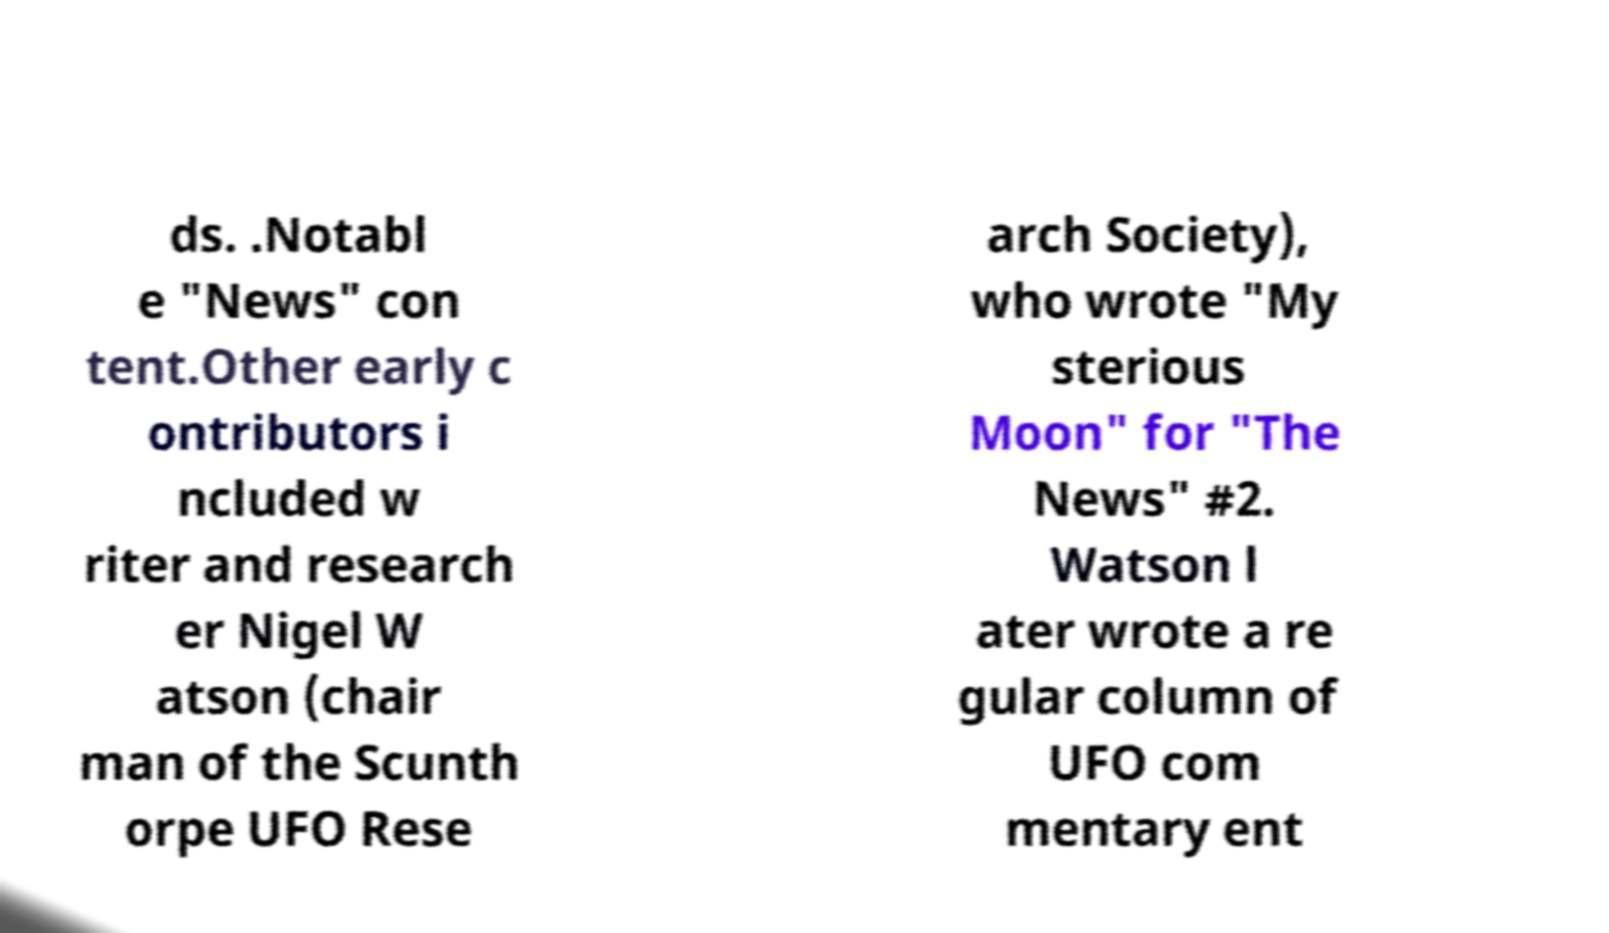For documentation purposes, I need the text within this image transcribed. Could you provide that? ds. .Notabl e "News" con tent.Other early c ontributors i ncluded w riter and research er Nigel W atson (chair man of the Scunth orpe UFO Rese arch Society), who wrote "My sterious Moon" for "The News" #2. Watson l ater wrote a re gular column of UFO com mentary ent 